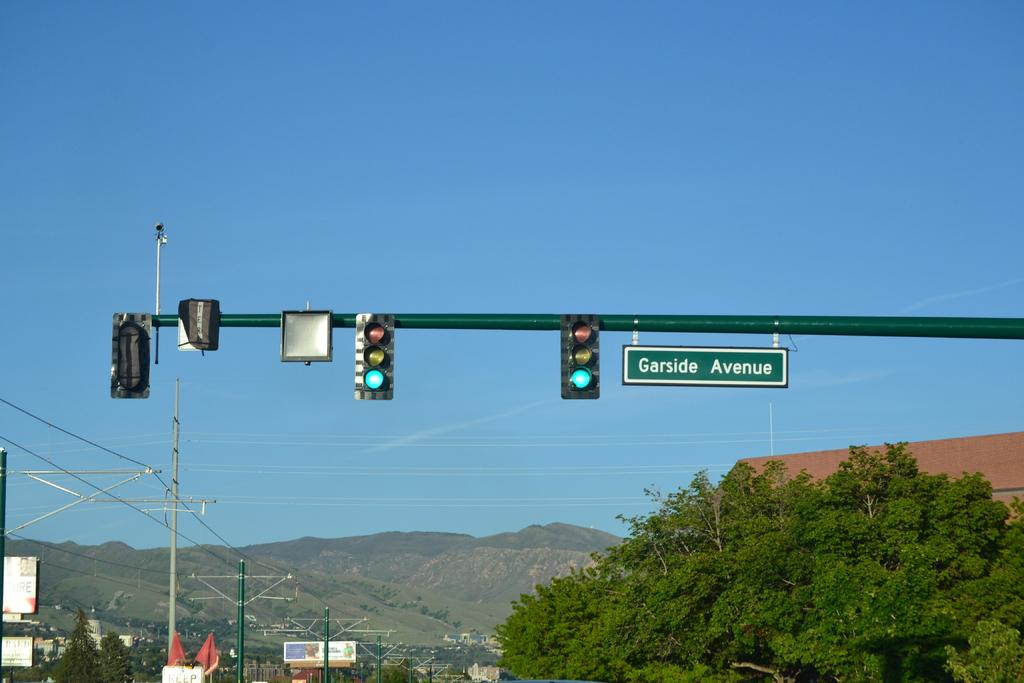<image>
Give a short and clear explanation of the subsequent image. Two traffic lights sit next to a street sign that reads garside avenue on it. 